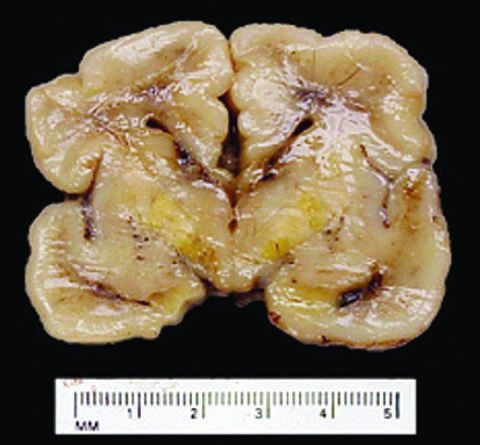do infants who survive develop long-term neurologic sequelae?
Answer the question using a single word or phrase. Yes 